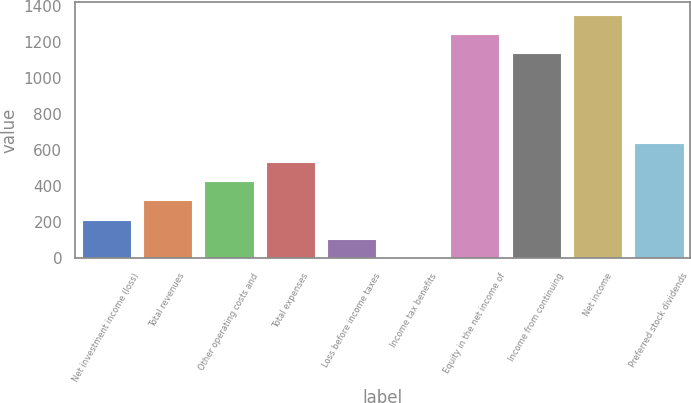Convert chart. <chart><loc_0><loc_0><loc_500><loc_500><bar_chart><fcel>Net investment income (loss)<fcel>Total revenues<fcel>Other operating costs and<fcel>Total expenses<fcel>Loss before income taxes<fcel>Income tax benefits<fcel>Equity in the net income of<fcel>Income from continuing<fcel>Net income<fcel>Preferred stock dividends<nl><fcel>214.62<fcel>320.83<fcel>427.04<fcel>533.25<fcel>108.41<fcel>2.2<fcel>1243.72<fcel>1137.51<fcel>1349.93<fcel>639.46<nl></chart> 